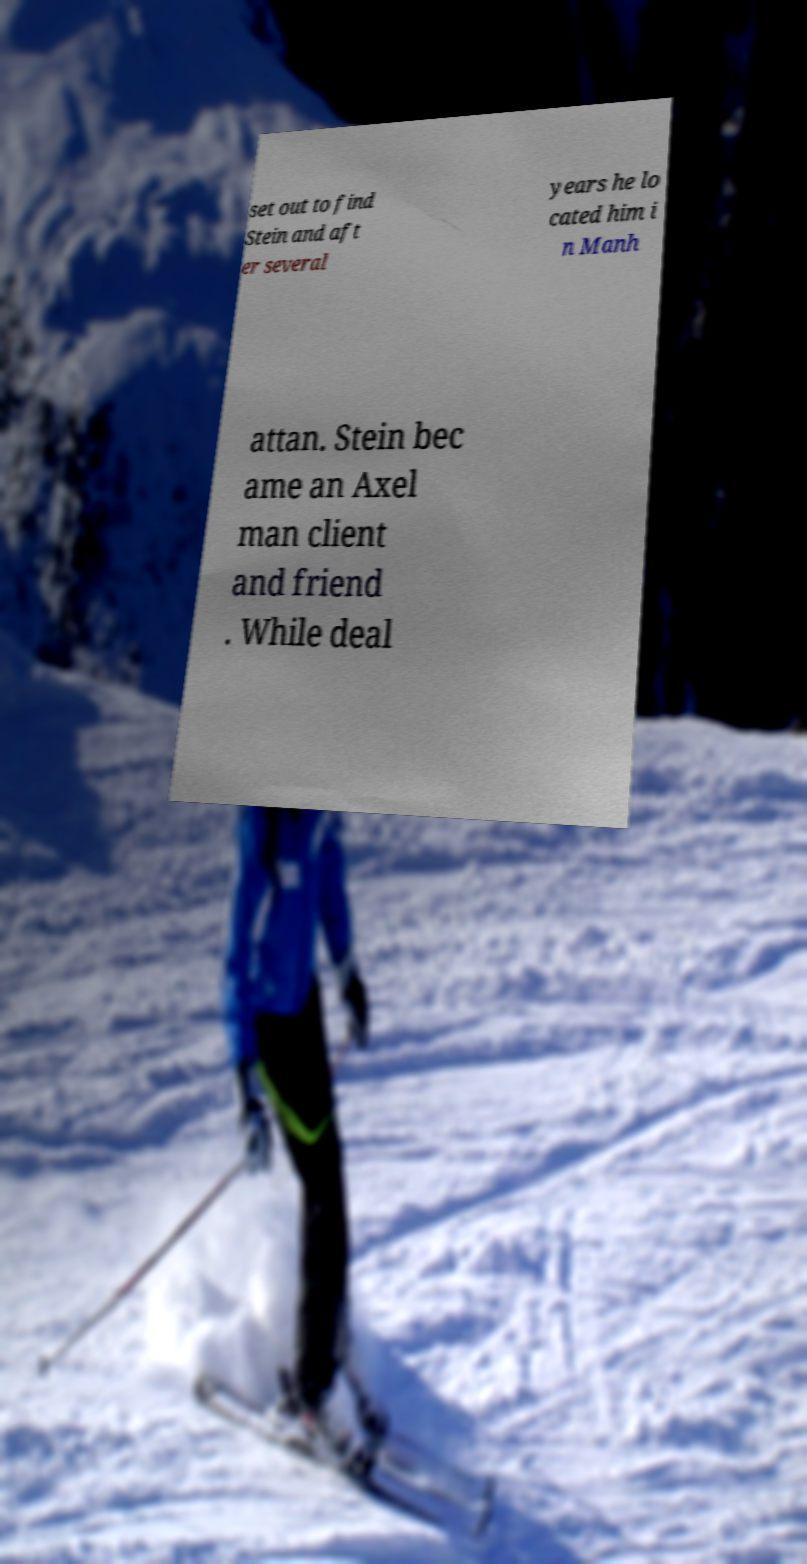Could you extract and type out the text from this image? set out to find Stein and aft er several years he lo cated him i n Manh attan. Stein bec ame an Axel man client and friend . While deal 